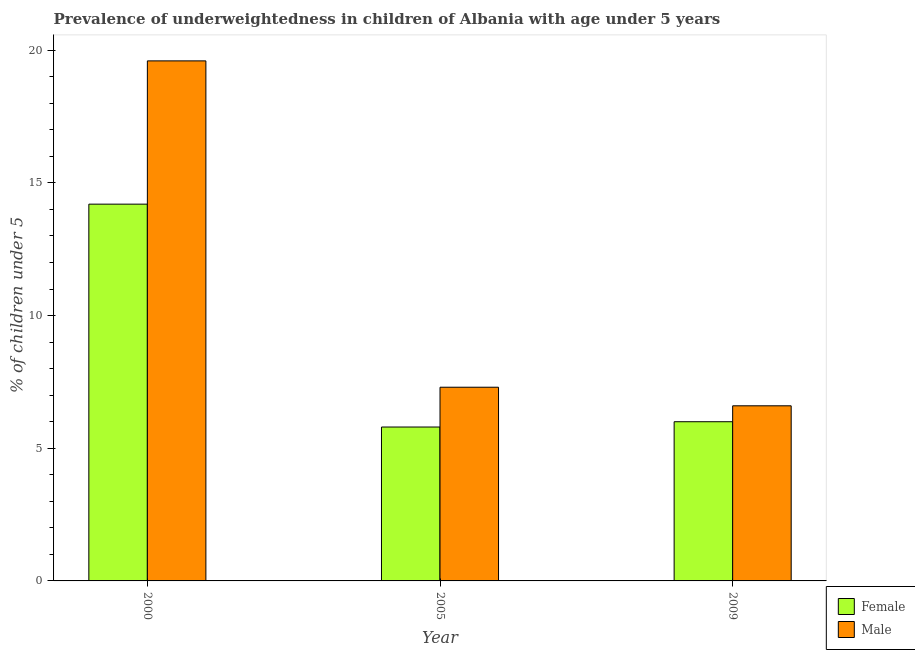How many groups of bars are there?
Offer a terse response. 3. Are the number of bars per tick equal to the number of legend labels?
Keep it short and to the point. Yes. Are the number of bars on each tick of the X-axis equal?
Your response must be concise. Yes. How many bars are there on the 2nd tick from the right?
Provide a succinct answer. 2. What is the percentage of underweighted male children in 2000?
Keep it short and to the point. 19.6. Across all years, what is the maximum percentage of underweighted male children?
Your response must be concise. 19.6. Across all years, what is the minimum percentage of underweighted female children?
Give a very brief answer. 5.8. In which year was the percentage of underweighted male children maximum?
Offer a very short reply. 2000. In which year was the percentage of underweighted female children minimum?
Your answer should be compact. 2005. What is the total percentage of underweighted male children in the graph?
Your response must be concise. 33.5. What is the difference between the percentage of underweighted female children in 2000 and that in 2009?
Make the answer very short. 8.2. What is the difference between the percentage of underweighted male children in 2009 and the percentage of underweighted female children in 2000?
Keep it short and to the point. -13. What is the average percentage of underweighted female children per year?
Ensure brevity in your answer.  8.67. In the year 2005, what is the difference between the percentage of underweighted male children and percentage of underweighted female children?
Your answer should be very brief. 0. What is the ratio of the percentage of underweighted female children in 2000 to that in 2005?
Give a very brief answer. 2.45. Is the percentage of underweighted female children in 2000 less than that in 2009?
Your response must be concise. No. Is the difference between the percentage of underweighted female children in 2000 and 2005 greater than the difference between the percentage of underweighted male children in 2000 and 2005?
Offer a terse response. No. What is the difference between the highest and the second highest percentage of underweighted male children?
Make the answer very short. 12.3. What is the difference between the highest and the lowest percentage of underweighted male children?
Offer a very short reply. 13. In how many years, is the percentage of underweighted male children greater than the average percentage of underweighted male children taken over all years?
Your answer should be very brief. 1. What does the 1st bar from the left in 2009 represents?
Give a very brief answer. Female. Are the values on the major ticks of Y-axis written in scientific E-notation?
Give a very brief answer. No. Does the graph contain grids?
Make the answer very short. No. How many legend labels are there?
Keep it short and to the point. 2. What is the title of the graph?
Give a very brief answer. Prevalence of underweightedness in children of Albania with age under 5 years. Does "Commercial bank branches" appear as one of the legend labels in the graph?
Make the answer very short. No. What is the label or title of the X-axis?
Offer a very short reply. Year. What is the label or title of the Y-axis?
Provide a short and direct response.  % of children under 5. What is the  % of children under 5 in Female in 2000?
Your answer should be compact. 14.2. What is the  % of children under 5 of Male in 2000?
Your answer should be very brief. 19.6. What is the  % of children under 5 in Female in 2005?
Offer a very short reply. 5.8. What is the  % of children under 5 in Male in 2005?
Your answer should be compact. 7.3. What is the  % of children under 5 of Male in 2009?
Keep it short and to the point. 6.6. Across all years, what is the maximum  % of children under 5 of Female?
Your answer should be compact. 14.2. Across all years, what is the maximum  % of children under 5 in Male?
Provide a succinct answer. 19.6. Across all years, what is the minimum  % of children under 5 in Female?
Your answer should be compact. 5.8. Across all years, what is the minimum  % of children under 5 in Male?
Give a very brief answer. 6.6. What is the total  % of children under 5 of Female in the graph?
Provide a short and direct response. 26. What is the total  % of children under 5 of Male in the graph?
Ensure brevity in your answer.  33.5. What is the difference between the  % of children under 5 of Male in 2000 and that in 2009?
Your answer should be very brief. 13. What is the difference between the  % of children under 5 in Male in 2005 and that in 2009?
Keep it short and to the point. 0.7. What is the difference between the  % of children under 5 in Female in 2000 and the  % of children under 5 in Male in 2009?
Make the answer very short. 7.6. What is the difference between the  % of children under 5 in Female in 2005 and the  % of children under 5 in Male in 2009?
Your answer should be compact. -0.8. What is the average  % of children under 5 in Female per year?
Provide a short and direct response. 8.67. What is the average  % of children under 5 of Male per year?
Your answer should be compact. 11.17. In the year 2000, what is the difference between the  % of children under 5 in Female and  % of children under 5 in Male?
Your response must be concise. -5.4. In the year 2005, what is the difference between the  % of children under 5 in Female and  % of children under 5 in Male?
Make the answer very short. -1.5. In the year 2009, what is the difference between the  % of children under 5 in Female and  % of children under 5 in Male?
Offer a terse response. -0.6. What is the ratio of the  % of children under 5 in Female in 2000 to that in 2005?
Your answer should be compact. 2.45. What is the ratio of the  % of children under 5 in Male in 2000 to that in 2005?
Your answer should be compact. 2.68. What is the ratio of the  % of children under 5 of Female in 2000 to that in 2009?
Ensure brevity in your answer.  2.37. What is the ratio of the  % of children under 5 in Male in 2000 to that in 2009?
Offer a very short reply. 2.97. What is the ratio of the  % of children under 5 in Female in 2005 to that in 2009?
Make the answer very short. 0.97. What is the ratio of the  % of children under 5 of Male in 2005 to that in 2009?
Your answer should be compact. 1.11. What is the difference between the highest and the second highest  % of children under 5 of Female?
Your response must be concise. 8.2. What is the difference between the highest and the second highest  % of children under 5 in Male?
Give a very brief answer. 12.3. What is the difference between the highest and the lowest  % of children under 5 of Male?
Your answer should be very brief. 13. 